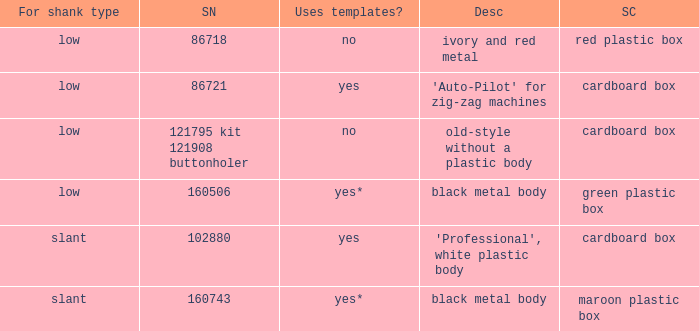What's the singer part number of the buttonholer whose storage case is a green plastic box? 160506.0. 